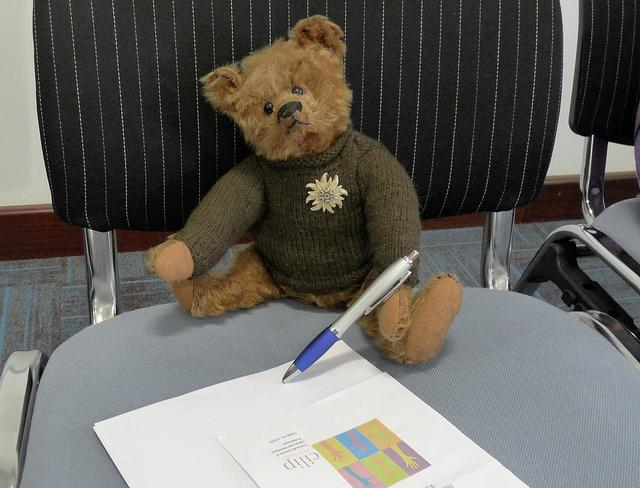What is the pen used to do on the paper? write 